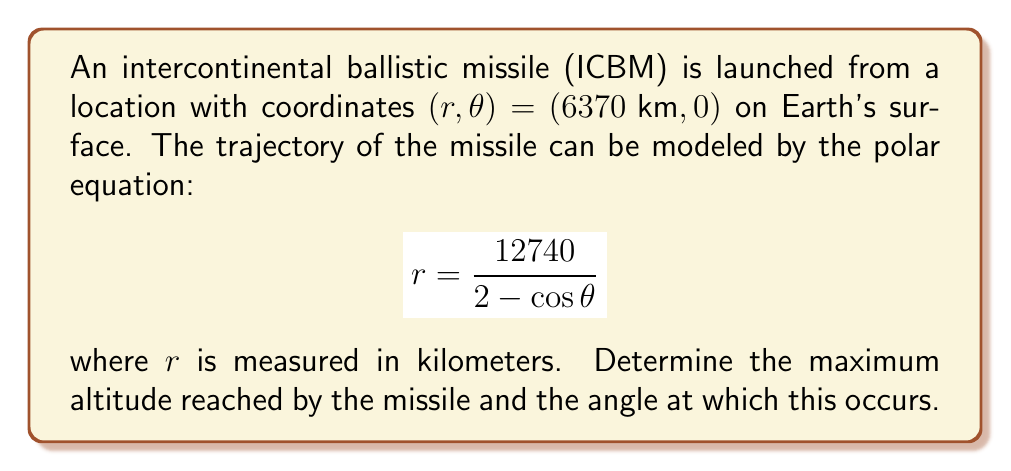Can you answer this question? To solve this problem, we need to follow these steps:

1) The maximum altitude occurs at the apogee of the trajectory, which is the point furthest from the Earth's center.

2) In polar coordinates, this corresponds to the maximum value of $r$.

3) To find the maximum $r$, we need to differentiate $r$ with respect to $\theta$ and set it equal to zero:

   $$\frac{dr}{d\theta} = \frac{12740 \sin \theta}{(2 - \cos \theta)^2} = 0$$

4) This equation is satisfied when $\sin \theta = 0$, which occurs at $\theta = 0°, 180°, 360°$, etc.

5) The relevant solution here is $\theta = 180°$, as this corresponds to the apogee.

6) To find the maximum $r$, we substitute $\theta = 180°$ into the original equation:

   $$r_{max} = \frac{12740}{2 - \cos 180°} = \frac{12740}{2 - (-1)} = \frac{12740}{3} \approx 4246.67 \text{ km}$$

7) The maximum altitude is the difference between this value and the Earth's radius (6370 km):

   $$\text{Maximum Altitude} = 4246.67 - 6370 = -2123.33 \text{ km}$$

   The negative sign indicates that this point is above the Earth's surface.

Therefore, the maximum altitude reached by the missile is approximately 2123.33 km, occurring at an angle of 180°.
Answer: Maximum altitude: 2123.33 km
Angle at maximum altitude: 180° 